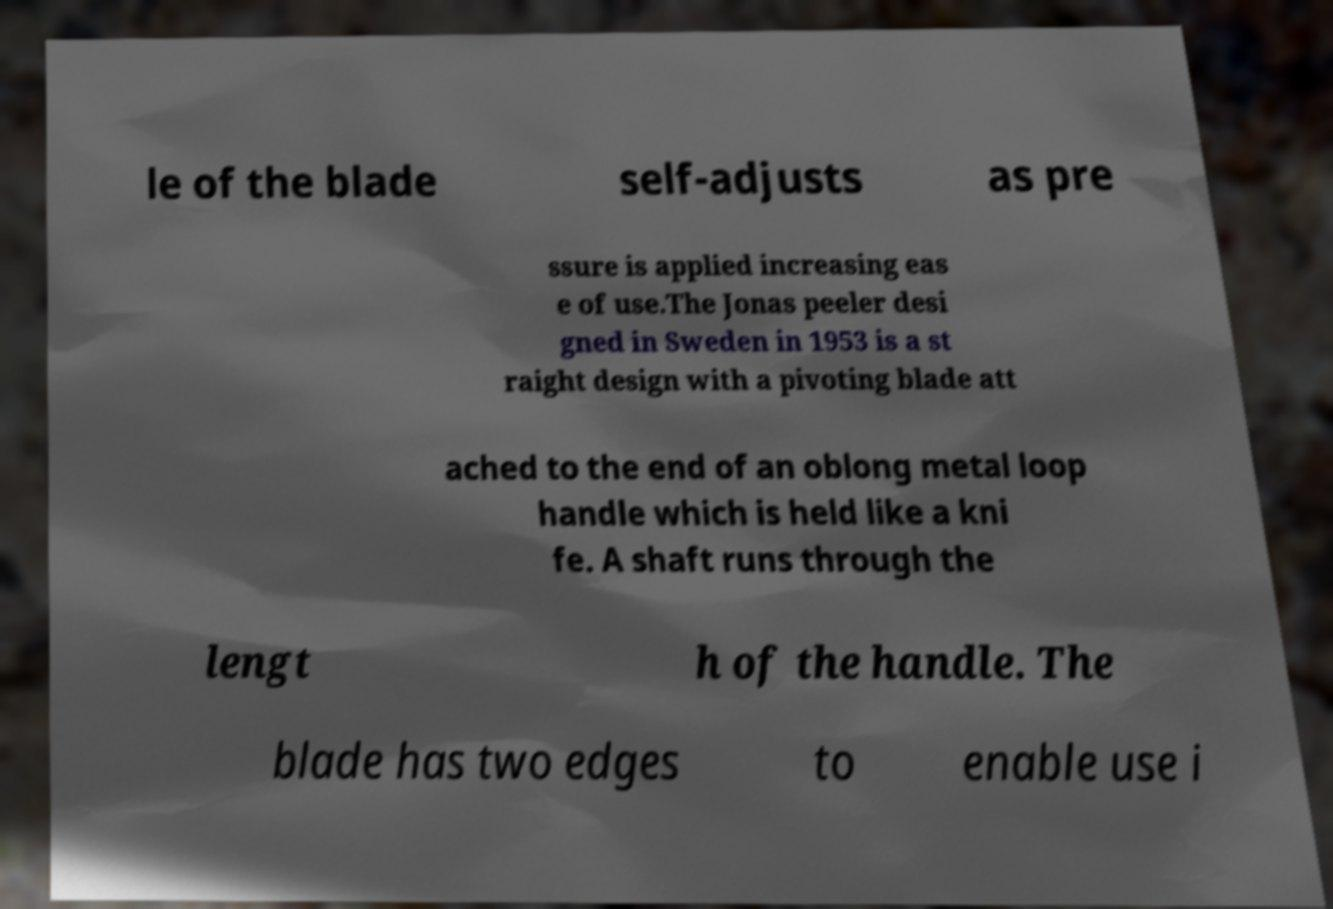Please identify and transcribe the text found in this image. le of the blade self-adjusts as pre ssure is applied increasing eas e of use.The Jonas peeler desi gned in Sweden in 1953 is a st raight design with a pivoting blade att ached to the end of an oblong metal loop handle which is held like a kni fe. A shaft runs through the lengt h of the handle. The blade has two edges to enable use i 